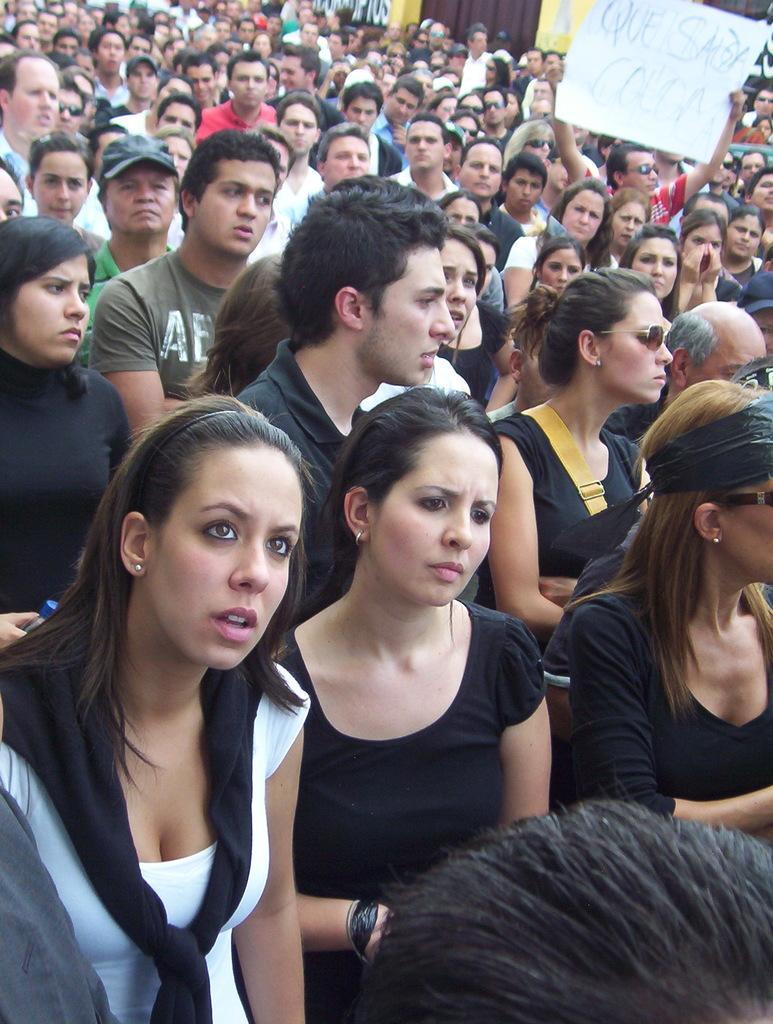How would you summarize this image in a sentence or two? In this image we can see a crowd. There is a person wearing goggles. He is holding a poster. Also we can see a person wearing a cap. 